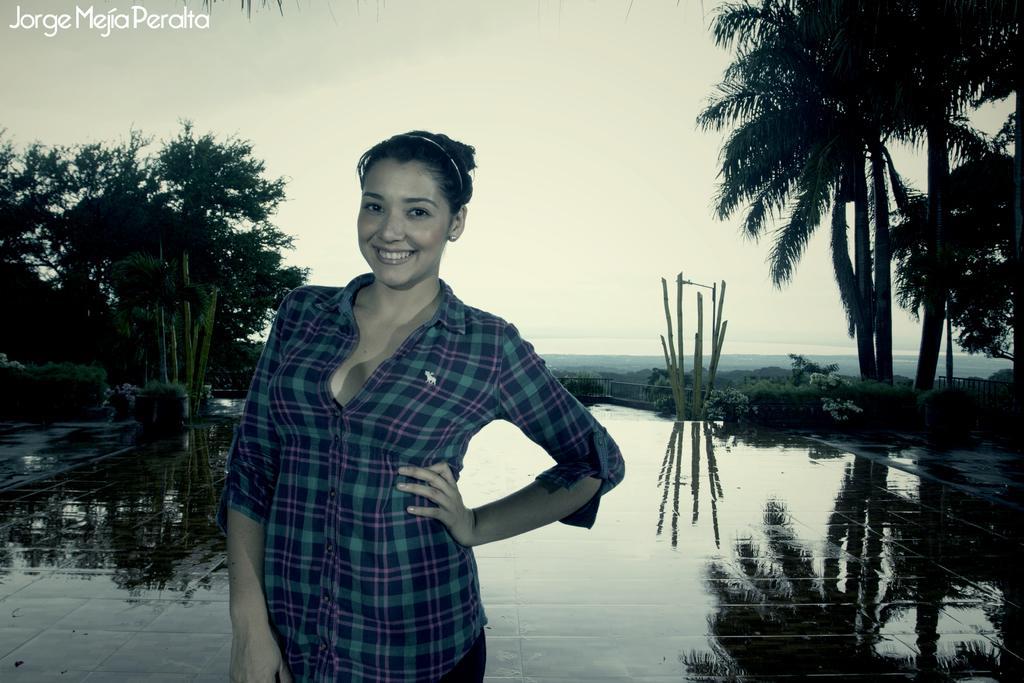Can you describe this image briefly? In this image I can see the person standing and the person is wearing blue and green color shirt. In the background I can see few plants and trees and the sky is in white color. 